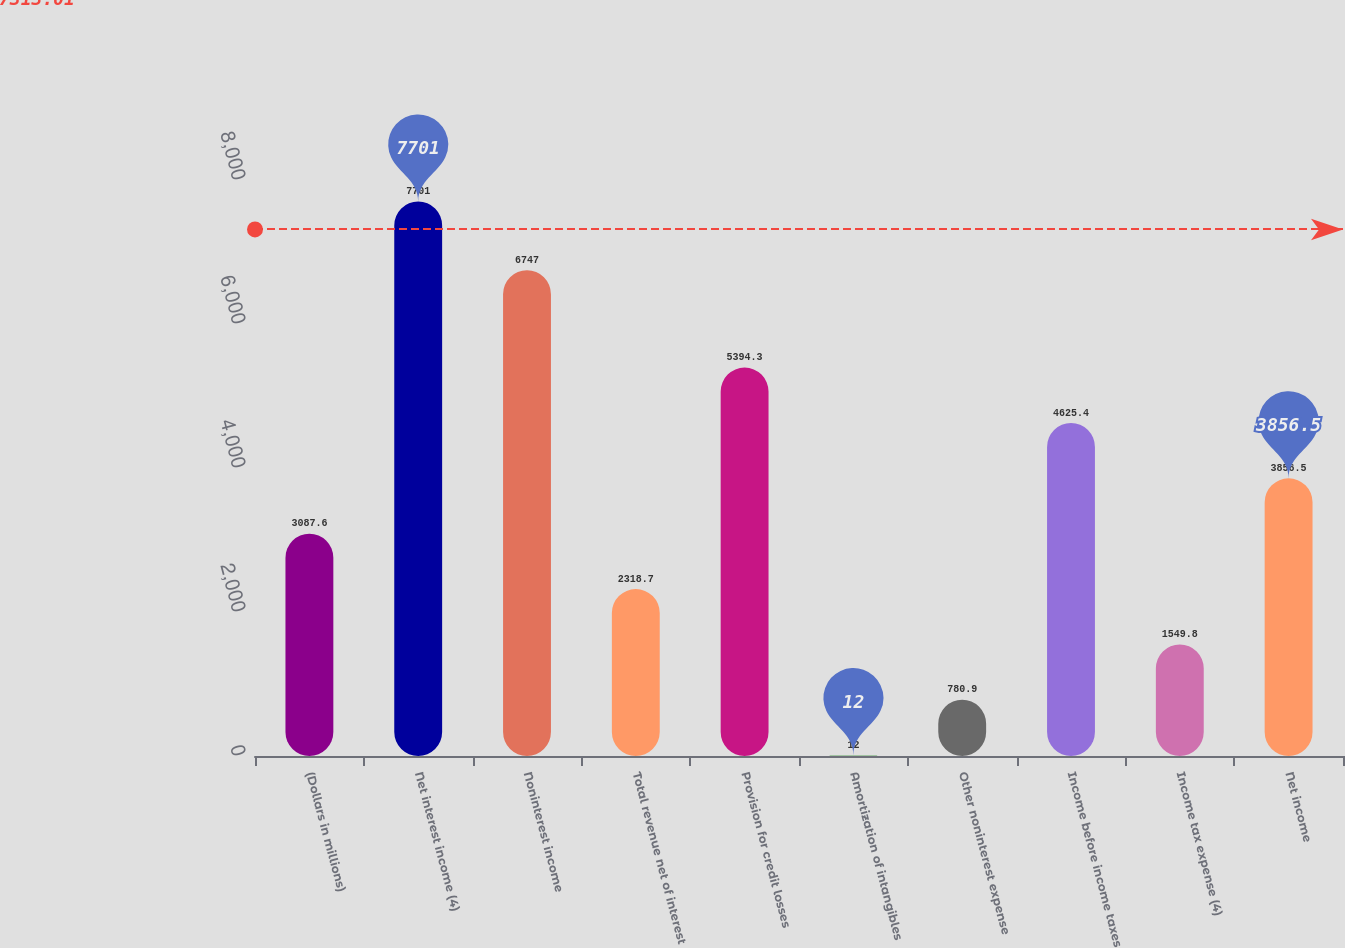Convert chart. <chart><loc_0><loc_0><loc_500><loc_500><bar_chart><fcel>(Dollars in millions)<fcel>Net interest income (4)<fcel>Noninterest income<fcel>Total revenue net of interest<fcel>Provision for credit losses<fcel>Amortization of intangibles<fcel>Other noninterest expense<fcel>Income before income taxes<fcel>Income tax expense (4)<fcel>Net income<nl><fcel>3087.6<fcel>7701<fcel>6747<fcel>2318.7<fcel>5394.3<fcel>12<fcel>780.9<fcel>4625.4<fcel>1549.8<fcel>3856.5<nl></chart> 